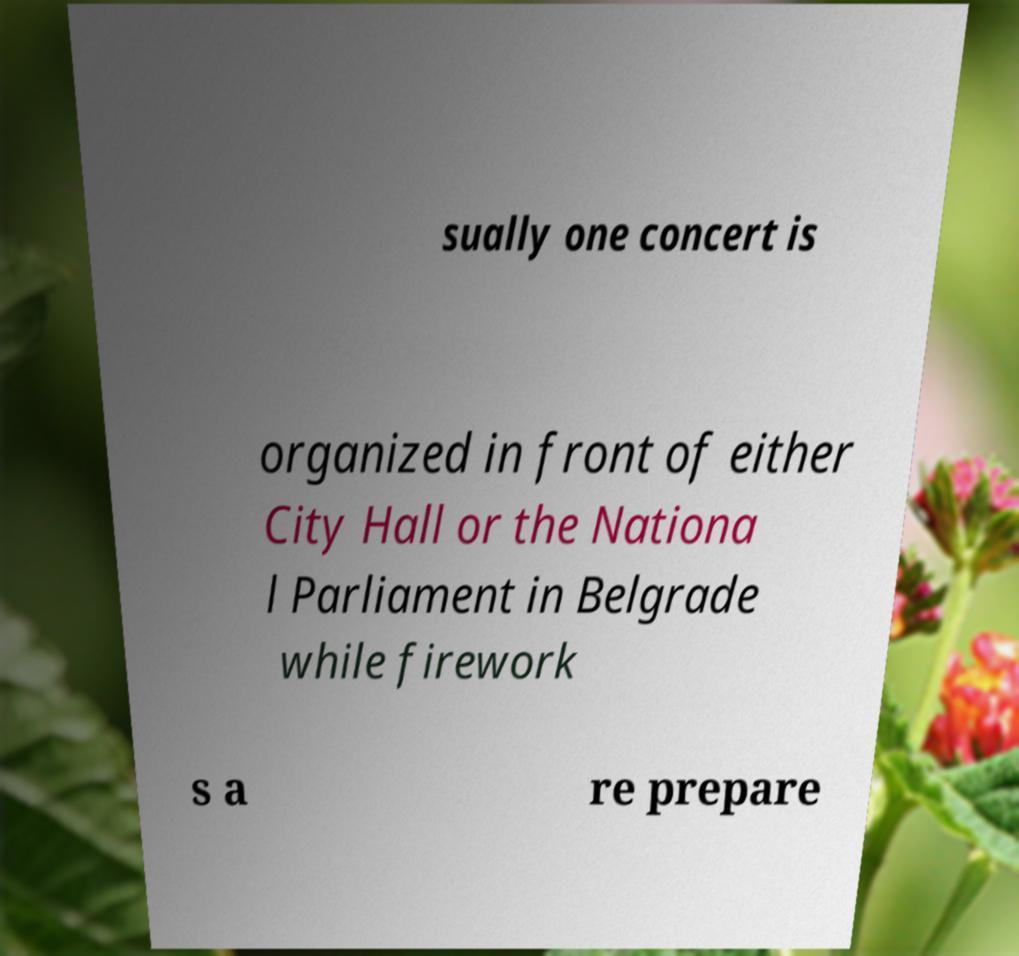What messages or text are displayed in this image? I need them in a readable, typed format. sually one concert is organized in front of either City Hall or the Nationa l Parliament in Belgrade while firework s a re prepare 